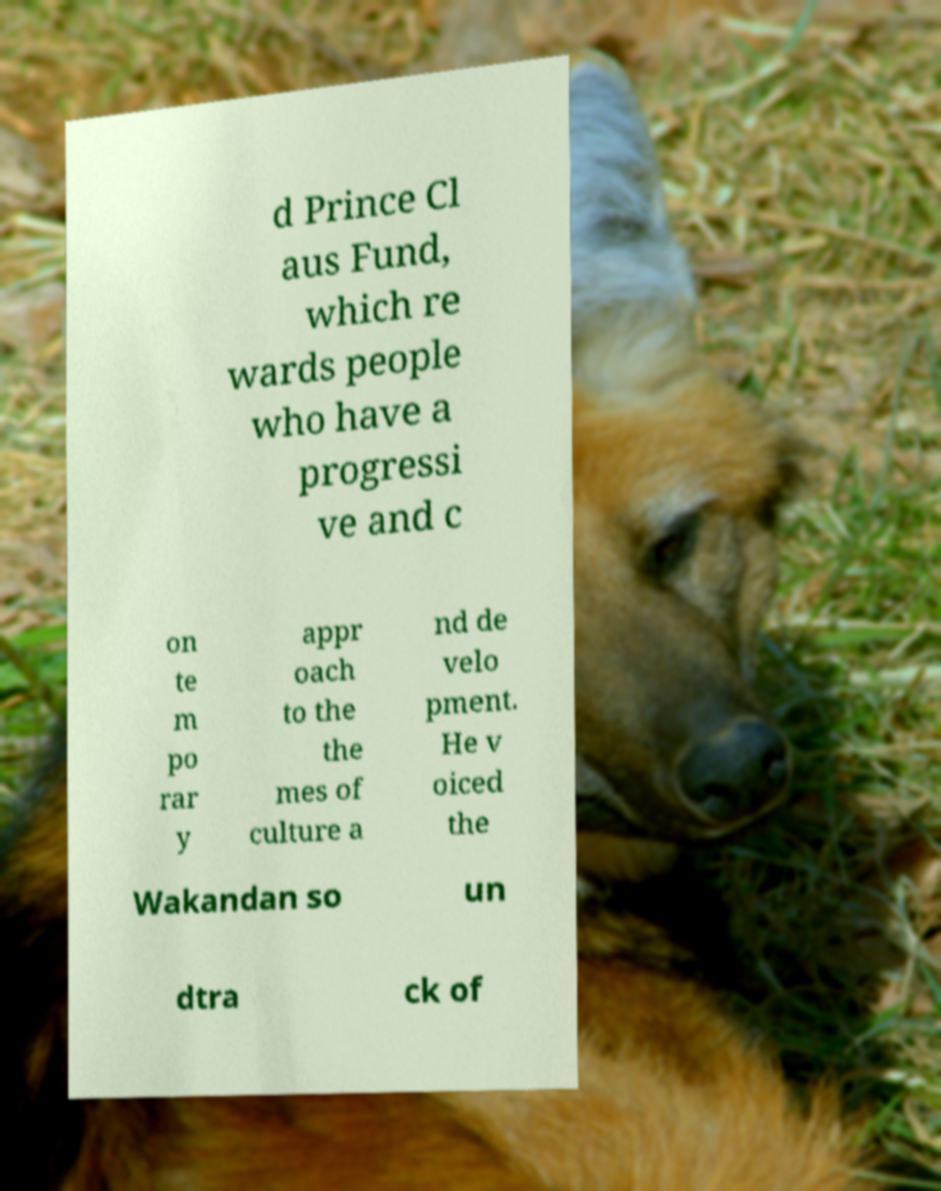Please read and relay the text visible in this image. What does it say? d Prince Cl aus Fund, which re wards people who have a progressi ve and c on te m po rar y appr oach to the the mes of culture a nd de velo pment. He v oiced the Wakandan so un dtra ck of 